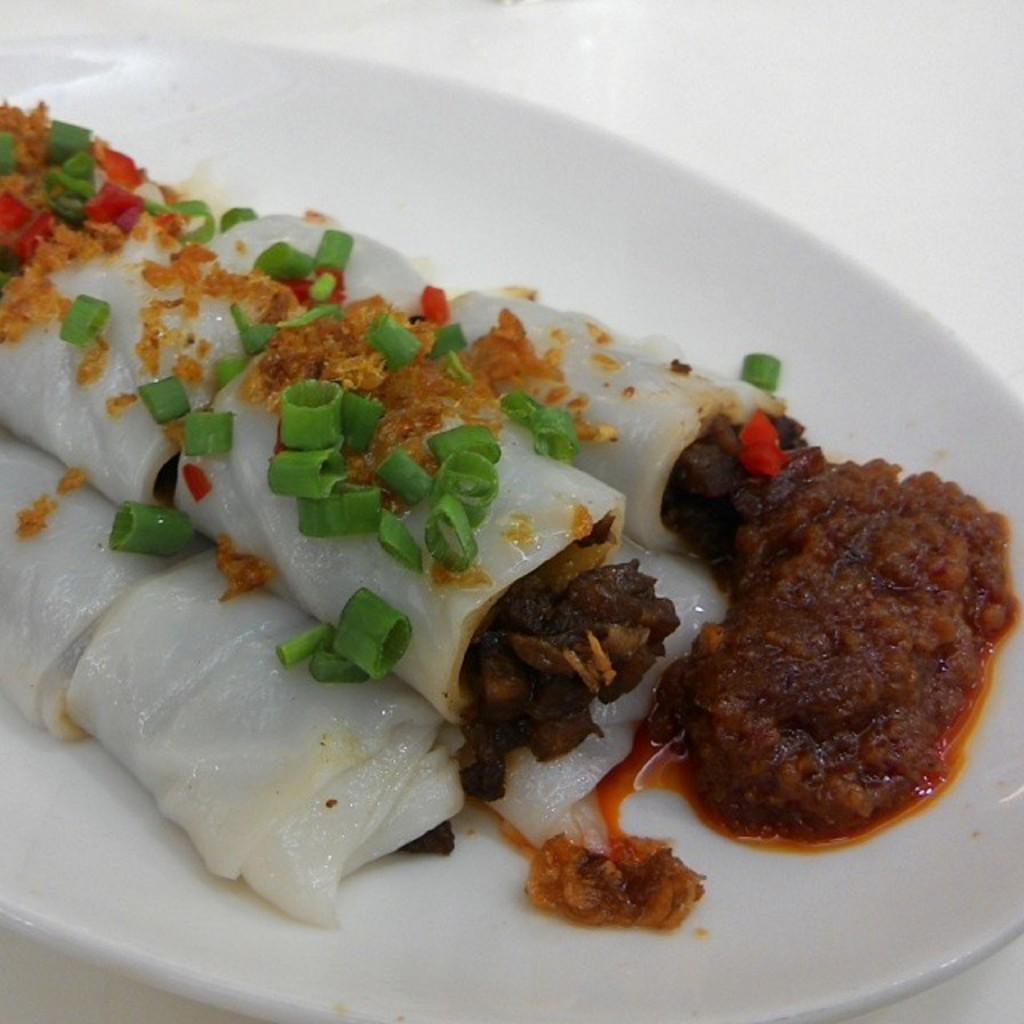How would you summarize this image in a sentence or two? In the image we can see a plate, white in color. On the plate we can see food items, chopped vegetables and chutney. 